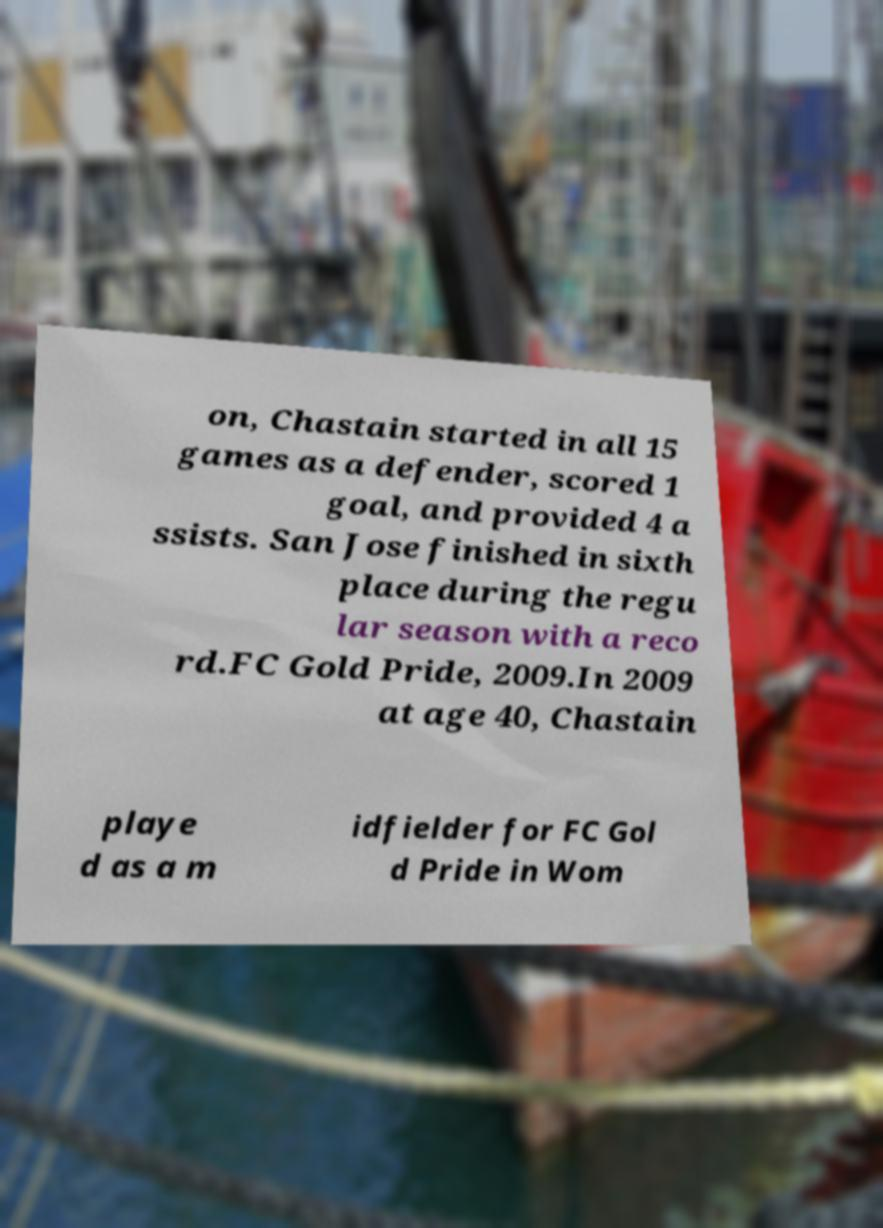What messages or text are displayed in this image? I need them in a readable, typed format. on, Chastain started in all 15 games as a defender, scored 1 goal, and provided 4 a ssists. San Jose finished in sixth place during the regu lar season with a reco rd.FC Gold Pride, 2009.In 2009 at age 40, Chastain playe d as a m idfielder for FC Gol d Pride in Wom 